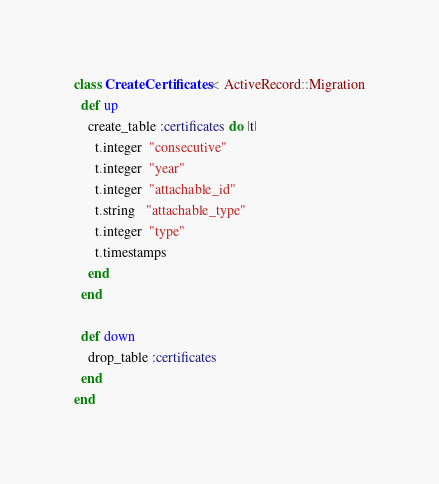Convert code to text. <code><loc_0><loc_0><loc_500><loc_500><_Ruby_>class CreateCertificates < ActiveRecord::Migration
  def up
    create_table :certificates do |t|
      t.integer  "consecutive"
      t.integer  "year"       
      t.integer  "attachable_id"
      t.string   "attachable_type"
      t.integer  "type"
      t.timestamps
    end 
  end

  def down
    drop_table :certificates
  end
end
</code> 